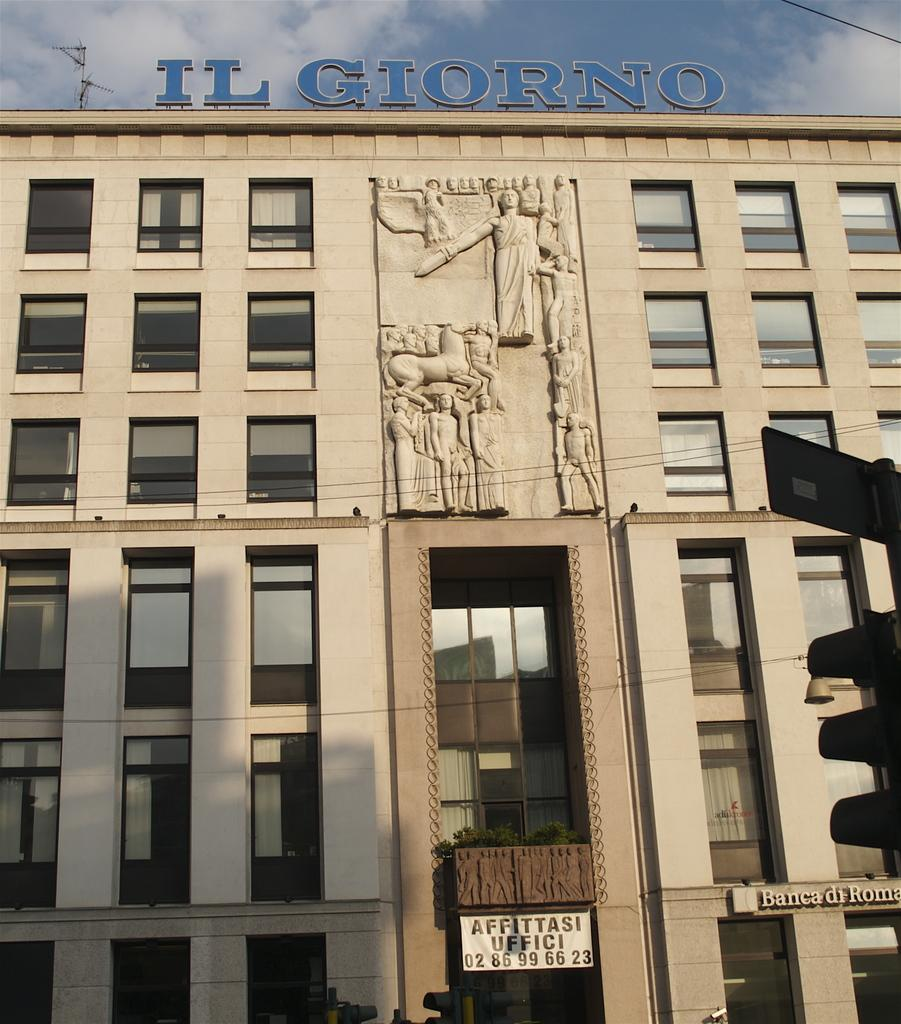What is the main structure in the picture? There is a building in the picture. What can be seen on the building? There is text on the building and carving on the wall of the building. How would you describe the sky in the picture? The sky is blue and cloudy. What is the taste of the bulb in the picture? There is no bulb present in the picture, so it cannot be tasted. 